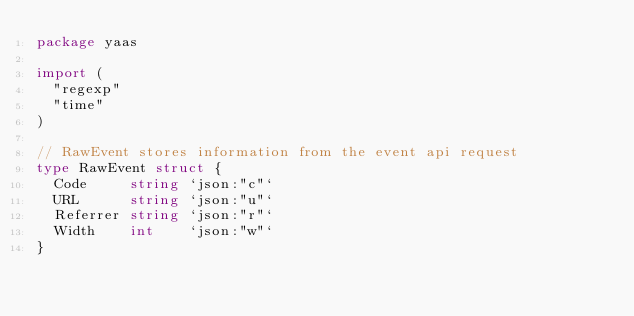<code> <loc_0><loc_0><loc_500><loc_500><_Go_>package yaas

import (
	"regexp"
	"time"
)

// RawEvent stores information from the event api request
type RawEvent struct {
	Code     string `json:"c"`
	URL      string `json:"u"`
	Referrer string `json:"r"`
	Width    int    `json:"w"`
}
</code> 